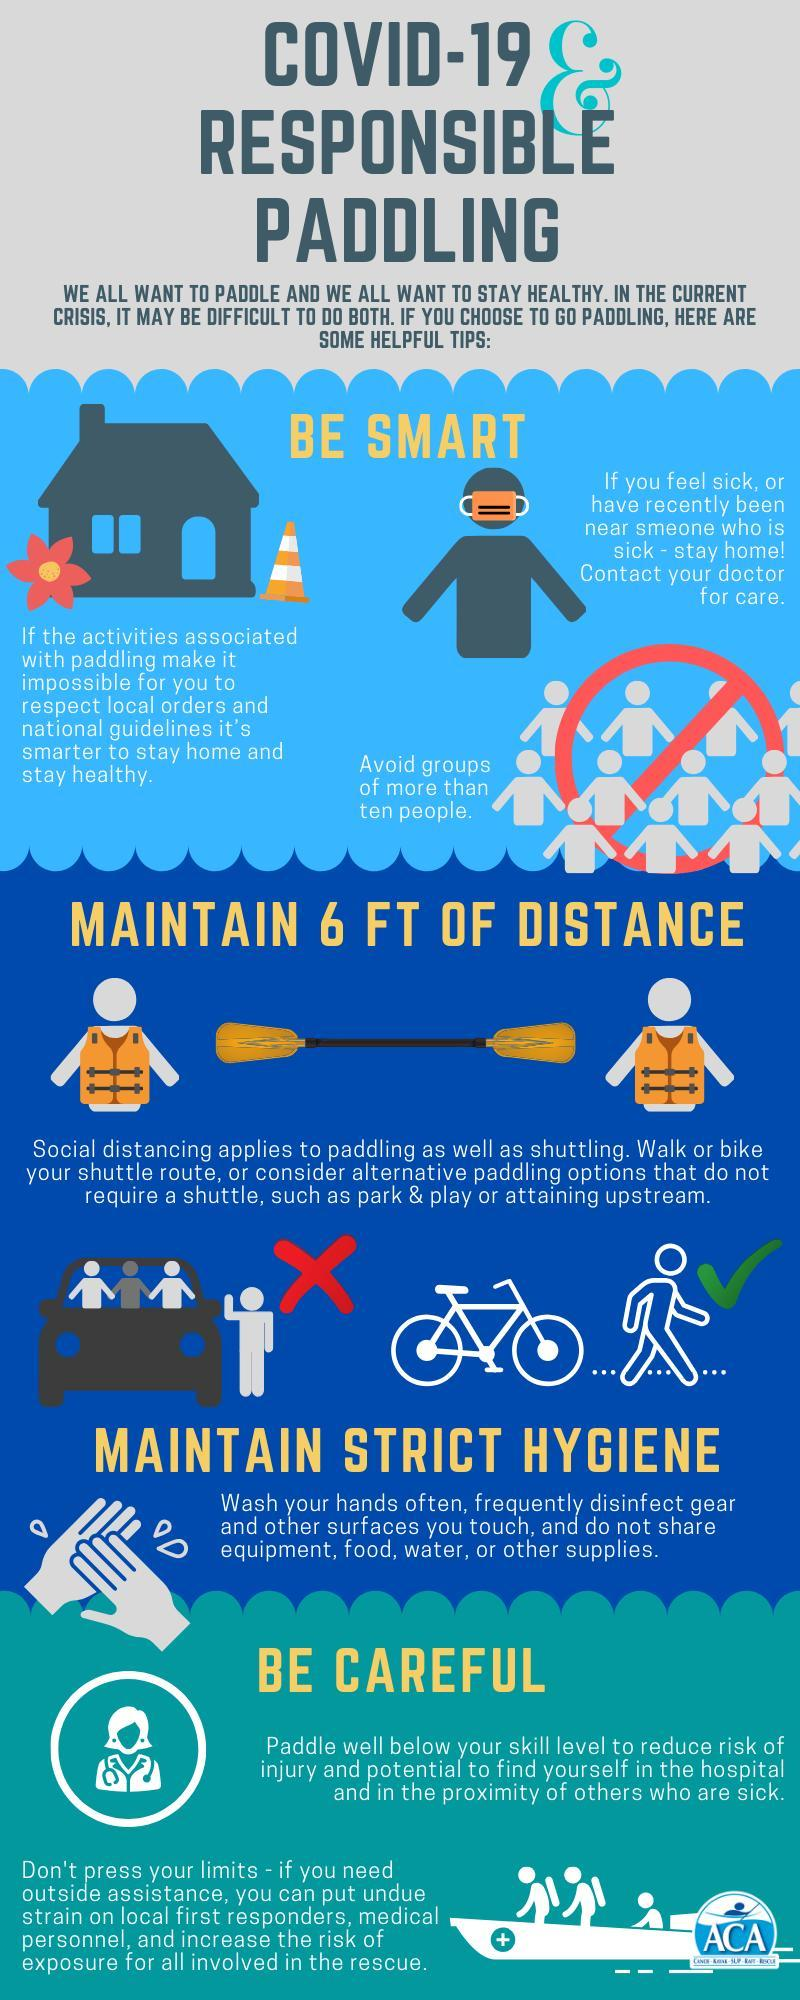Which modes of transport are better than shuttling?
Answer the question with a short phrase. walk or bike What should be the maximum number of people in a group? ten What should be done if you have been in the proximity of a sick person? stay home 